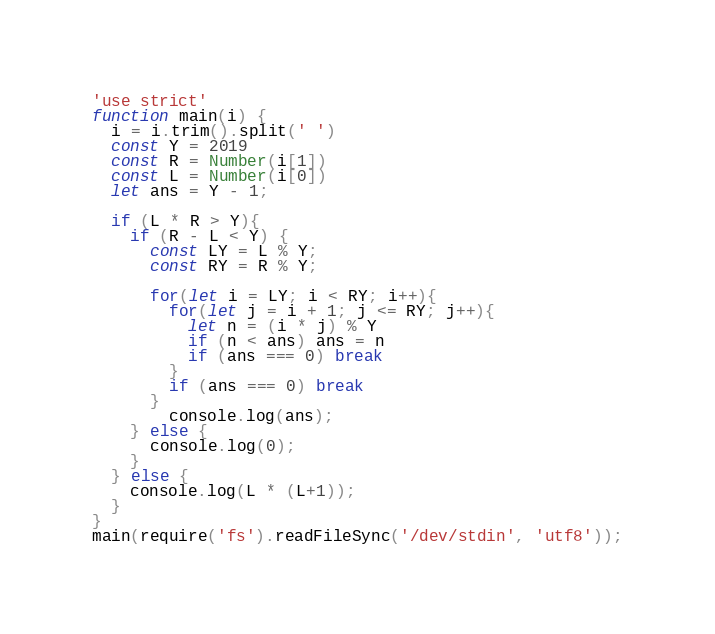<code> <loc_0><loc_0><loc_500><loc_500><_JavaScript_>'use strict'
function main(i) {
  i = i.trim().split(' ')
  const Y = 2019
  const R = Number(i[1])
  const L = Number(i[0])
  let ans = Y - 1;

  if (L * R > Y){
    if (R - L < Y) {
      const LY = L % Y;
      const RY = R % Y;

      for(let i = LY; i < RY; i++){
        for(let j = i + 1; j <= RY; j++){
          let n = (i * j) % Y
          if (n < ans) ans = n
          if (ans === 0) break
        }
        if (ans === 0) break
      }
	    console.log(ans);
    } else {
      console.log(0);
    }
  } else {
    console.log(L * (L+1));
  }
}
main(require('fs').readFileSync('/dev/stdin', 'utf8'));
</code> 